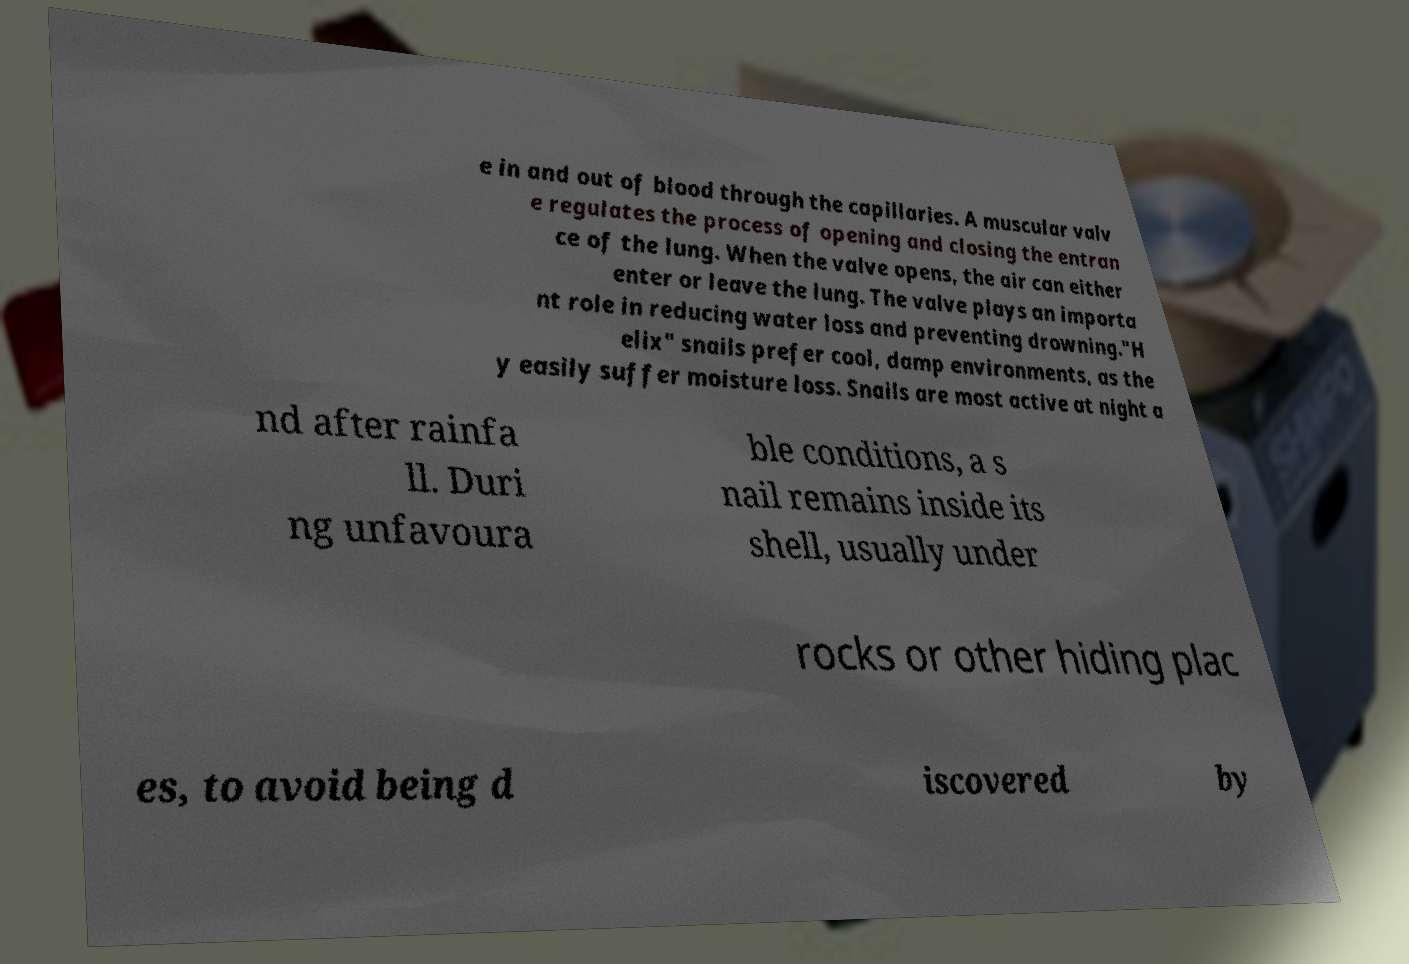Could you assist in decoding the text presented in this image and type it out clearly? e in and out of blood through the capillaries. A muscular valv e regulates the process of opening and closing the entran ce of the lung. When the valve opens, the air can either enter or leave the lung. The valve plays an importa nt role in reducing water loss and preventing drowning."H elix" snails prefer cool, damp environments, as the y easily suffer moisture loss. Snails are most active at night a nd after rainfa ll. Duri ng unfavoura ble conditions, a s nail remains inside its shell, usually under rocks or other hiding plac es, to avoid being d iscovered by 